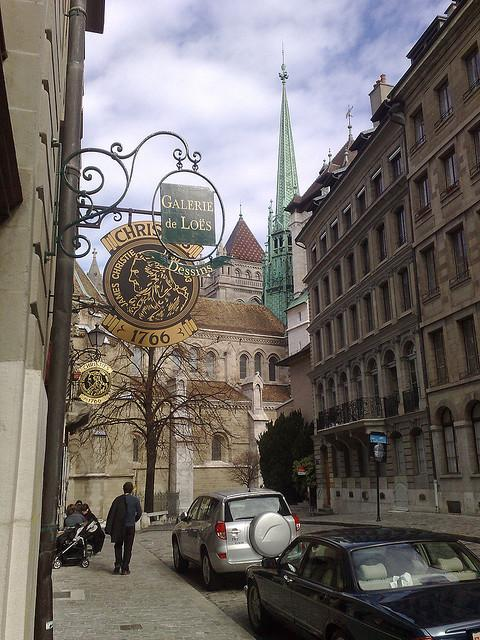Where is there most likely to be a baby at in this picture? Please explain your reasoning. stroller. This is a vehicle for small children 